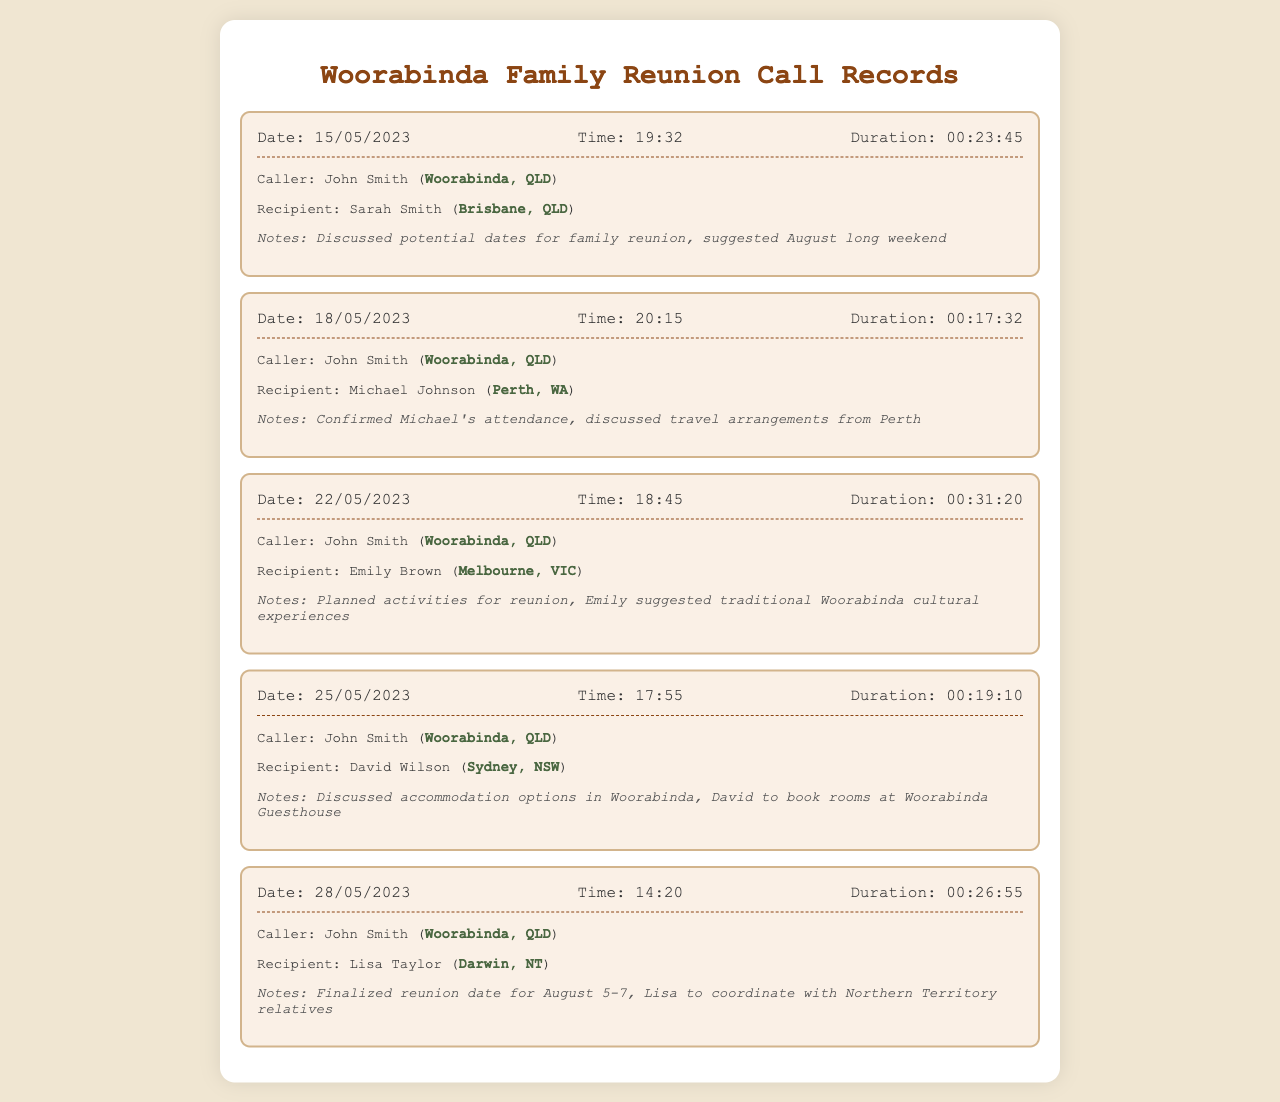What date was the call made to Sarah Smith? This information is found in the call details section for the date the call was made.
Answer: 15/05/2023 What location does John Smith call from? John Smith is identified as the caller in each record, and his location is mentioned consistently.
Answer: Woorabinda, QLD How long was the call with Emily Brown? The duration of the call is specified in the details of that call record.
Answer: 00:31:20 What was suggested for the family reunion date? The notes from the call with Lisa Taylor mention the finalized reunion date.
Answer: August 5-7 Who was responsible for booking rooms at Woorabinda Guesthouse? The notes from the call with David Wilson specify who would book the accommodation.
Answer: David Which recipient is from Perth? The call records indicate the location of each recipient alongside their names.
Answer: Michael Johnson What was discussed during the call with Sarah Smith? The notes provide insight into the discussion topics for each call.
Answer: Potential dates for family reunion What cultural experiences did Emily Brown suggest? Notes from the call with Emily Brown highlight her suggestion about the reunion.
Answer: Traditional Woorabinda cultural experiences How many calls were made in total? The number of unique call records listed in the document indicates total calls made.
Answer: 5 